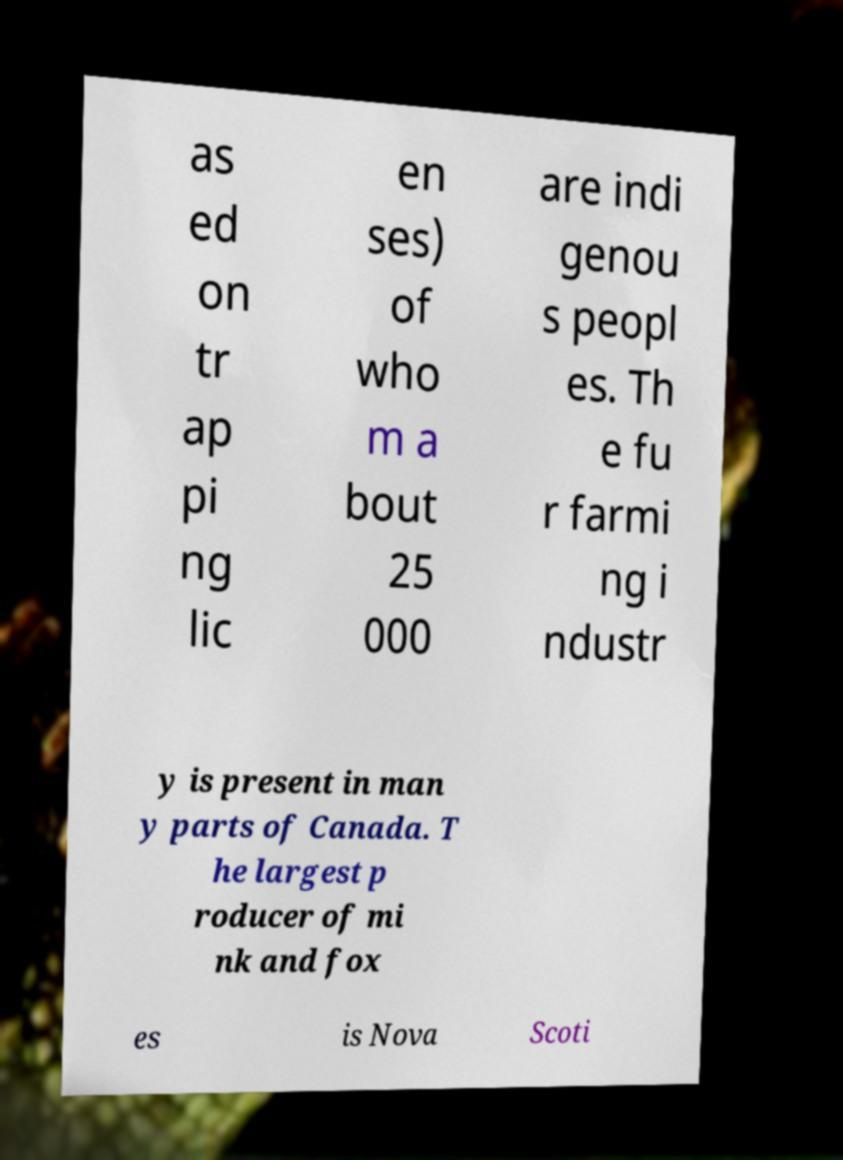There's text embedded in this image that I need extracted. Can you transcribe it verbatim? as ed on tr ap pi ng lic en ses) of who m a bout 25 000 are indi genou s peopl es. Th e fu r farmi ng i ndustr y is present in man y parts of Canada. T he largest p roducer of mi nk and fox es is Nova Scoti 